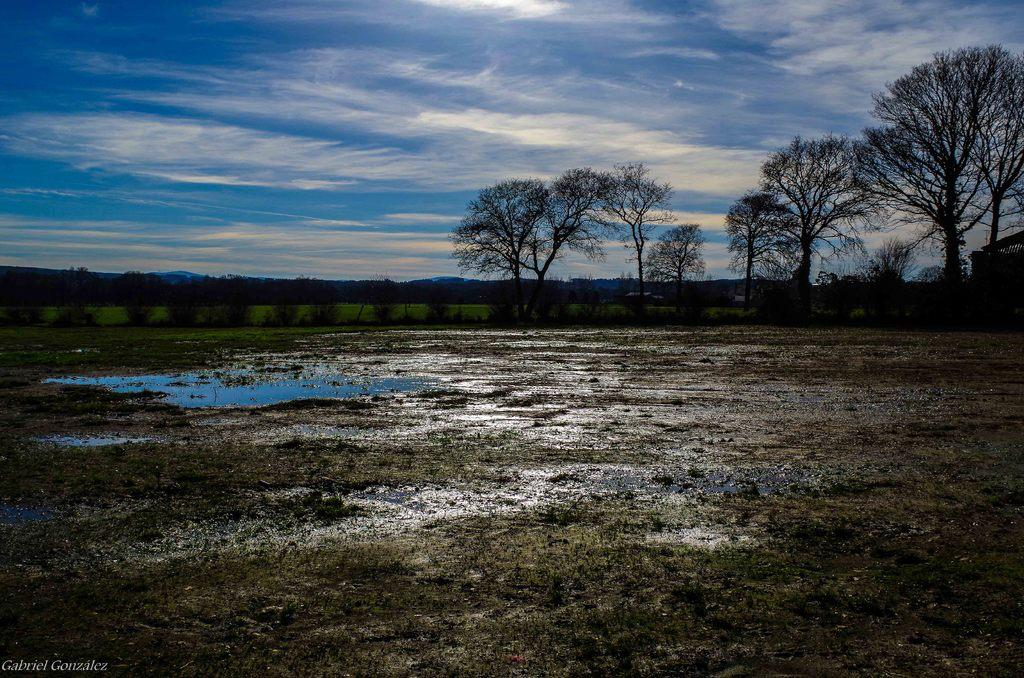What type of environment is shown in the image? The image depicts a wetland. What can be seen growing in the wetland? The wetland is covered with trees. What is visible at the top of the image? The sky is visible at the top of the image. How many times has the tree been smashed in the image? There is no indication of any trees being smashed in the image. What type of wound can be seen on the tree in the image? There are no visible wounds on any trees in the image. 